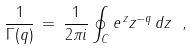Convert formula to latex. <formula><loc_0><loc_0><loc_500><loc_500>\frac { 1 } { \Gamma ( q ) } \, = \, \frac { 1 } { 2 \pi i } \oint _ { C } e ^ { \, z } z ^ { - q } \, d z \ ,</formula> 